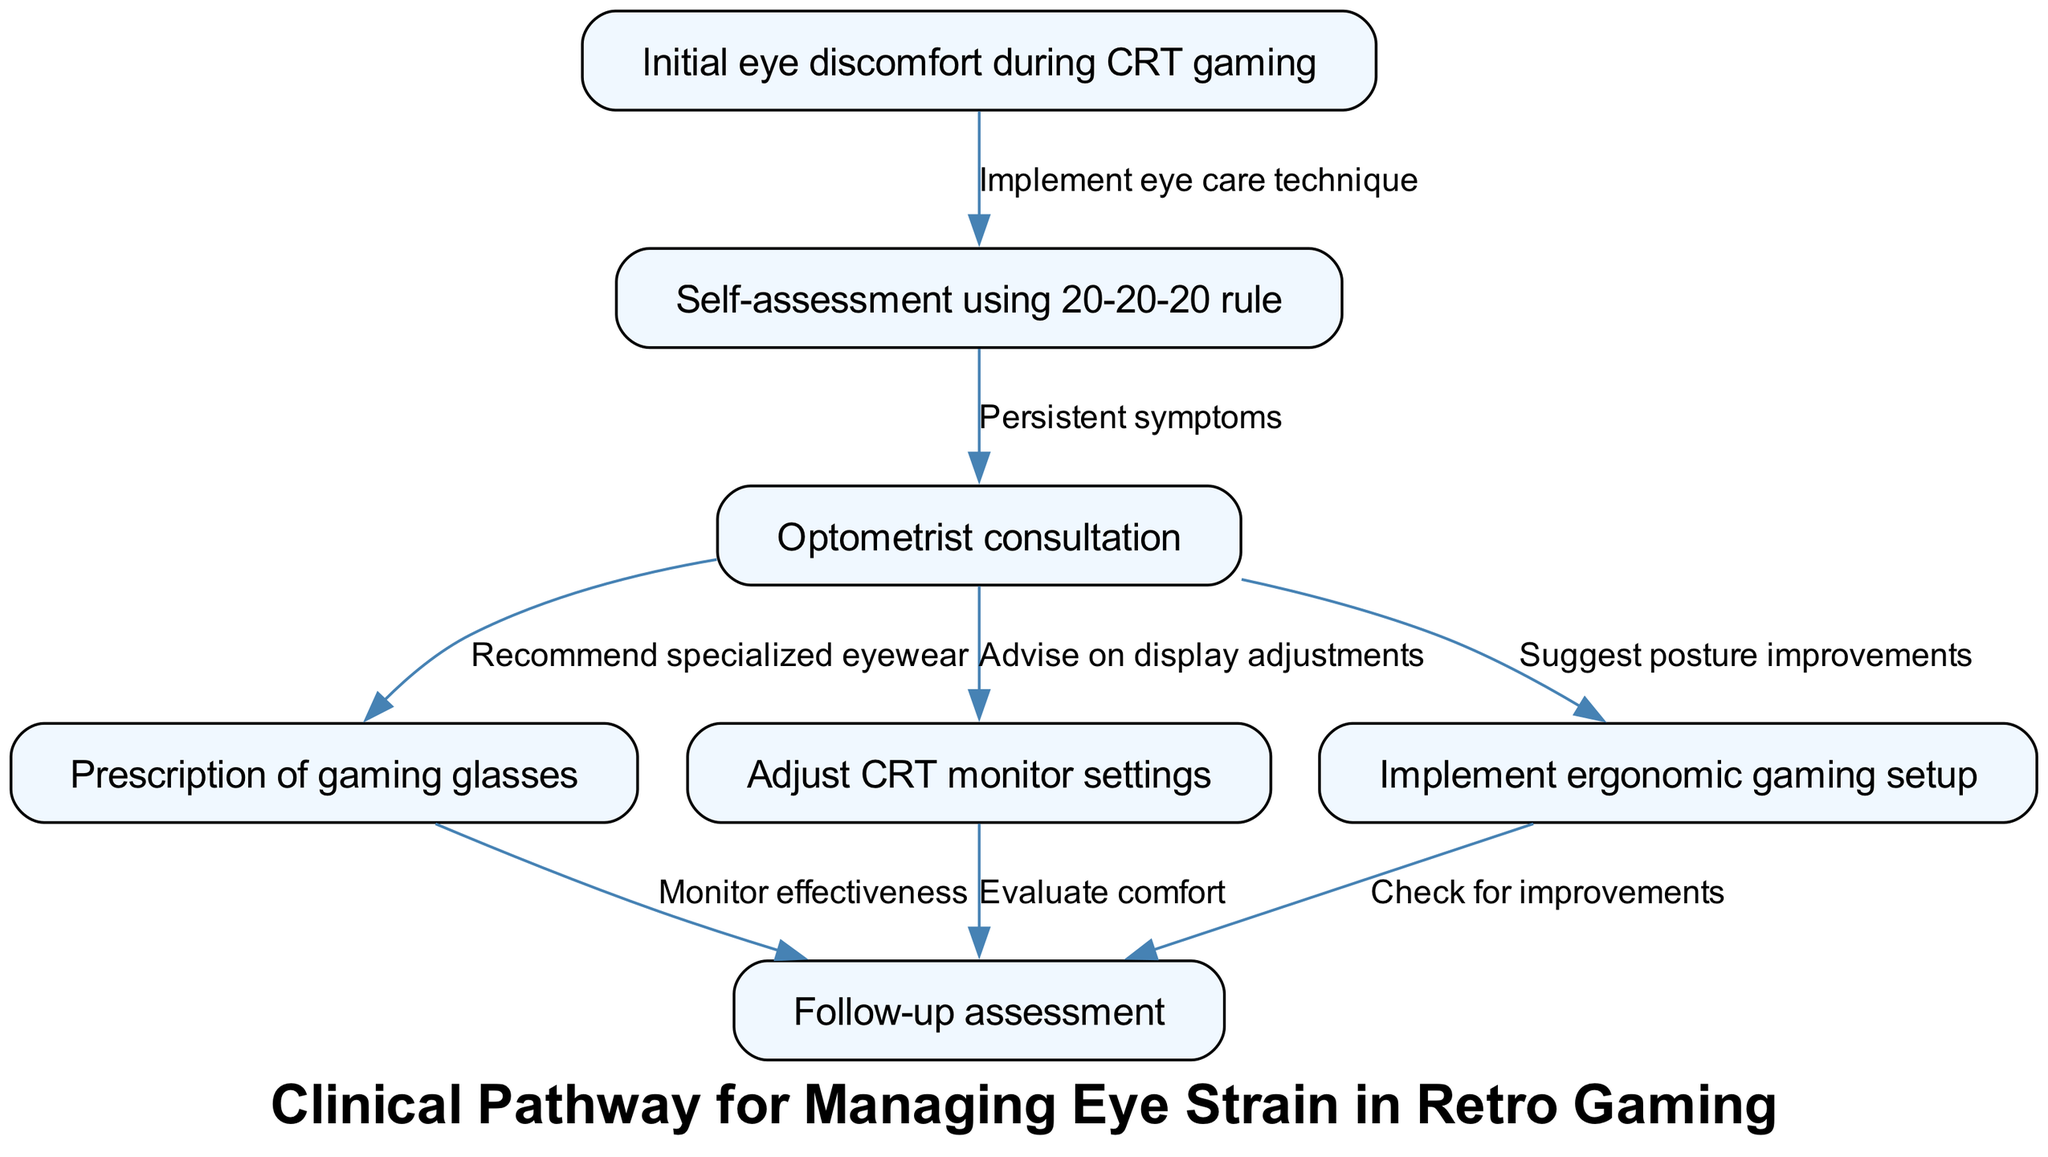What is the first step in the clinical pathway? The first node in the diagram represents the initial step, which indicates the occurrence of initial eye discomfort during CRT gaming.
Answer: Initial eye discomfort during CRT gaming How many nodes are in the diagram? By counting all individual nodes listed in the diagram, there are seven nodes present outlining the patient journey.
Answer: 7 What is the relationship between node 1 and node 2? The edge from node 1 (Initial eye discomfort during CRT gaming) to node 2 (Self-assessment using 20-20-20 rule) states "Implement eye care technique," indicating that the discomfort prompts the use of eye care techniques.
Answer: Implement eye care technique What follow-up comes after the prescription of gaming glasses? The edge stemming from node 4 indicates that the follow-up assessment occurs after the prescription of gaming glasses so that effectiveness can be monitored.
Answer: Monitor effectiveness What are two recommendations given during the optometrist consultation? The optometrist consultation node branches out to three recommendations: "Recommend specialized eyewear," "Advise on display adjustments," and "Suggest posture improvements," and two of these can be taken together to form the answer.
Answer: Recommend specialized eyewear and Advise on display adjustments If someone has persistent symptoms after self-assessment, what is the next step? In the diagram, persistent symptoms following self-assessment lead to the optometrist consultation, which is the direct next step for the patient.
Answer: Optometrist consultation What aspect of gaming does the node 'Implement ergonomic gaming setup' address? This node focuses on creating a comfortable and health-oriented gaming environment to help alleviate eye strain and improve posture during gaming sessions.
Answer: Posture improvements How many edges connect to the follow-up assessment node? By reviewing the connections leading to node 7 (Follow-up assessment), there are three edges coming from nodes 4, 5, and 6, which relate to monitoring and evaluating effects after different interventions.
Answer: 3 What should be done if a patient experiences initial eye discomfort? The following step suggests performing a self-assessment using the 20-20-20 rule, which helps in managing the eye discomfort before seeking further assistance.
Answer: Self-assessment using 20-20-20 rule 